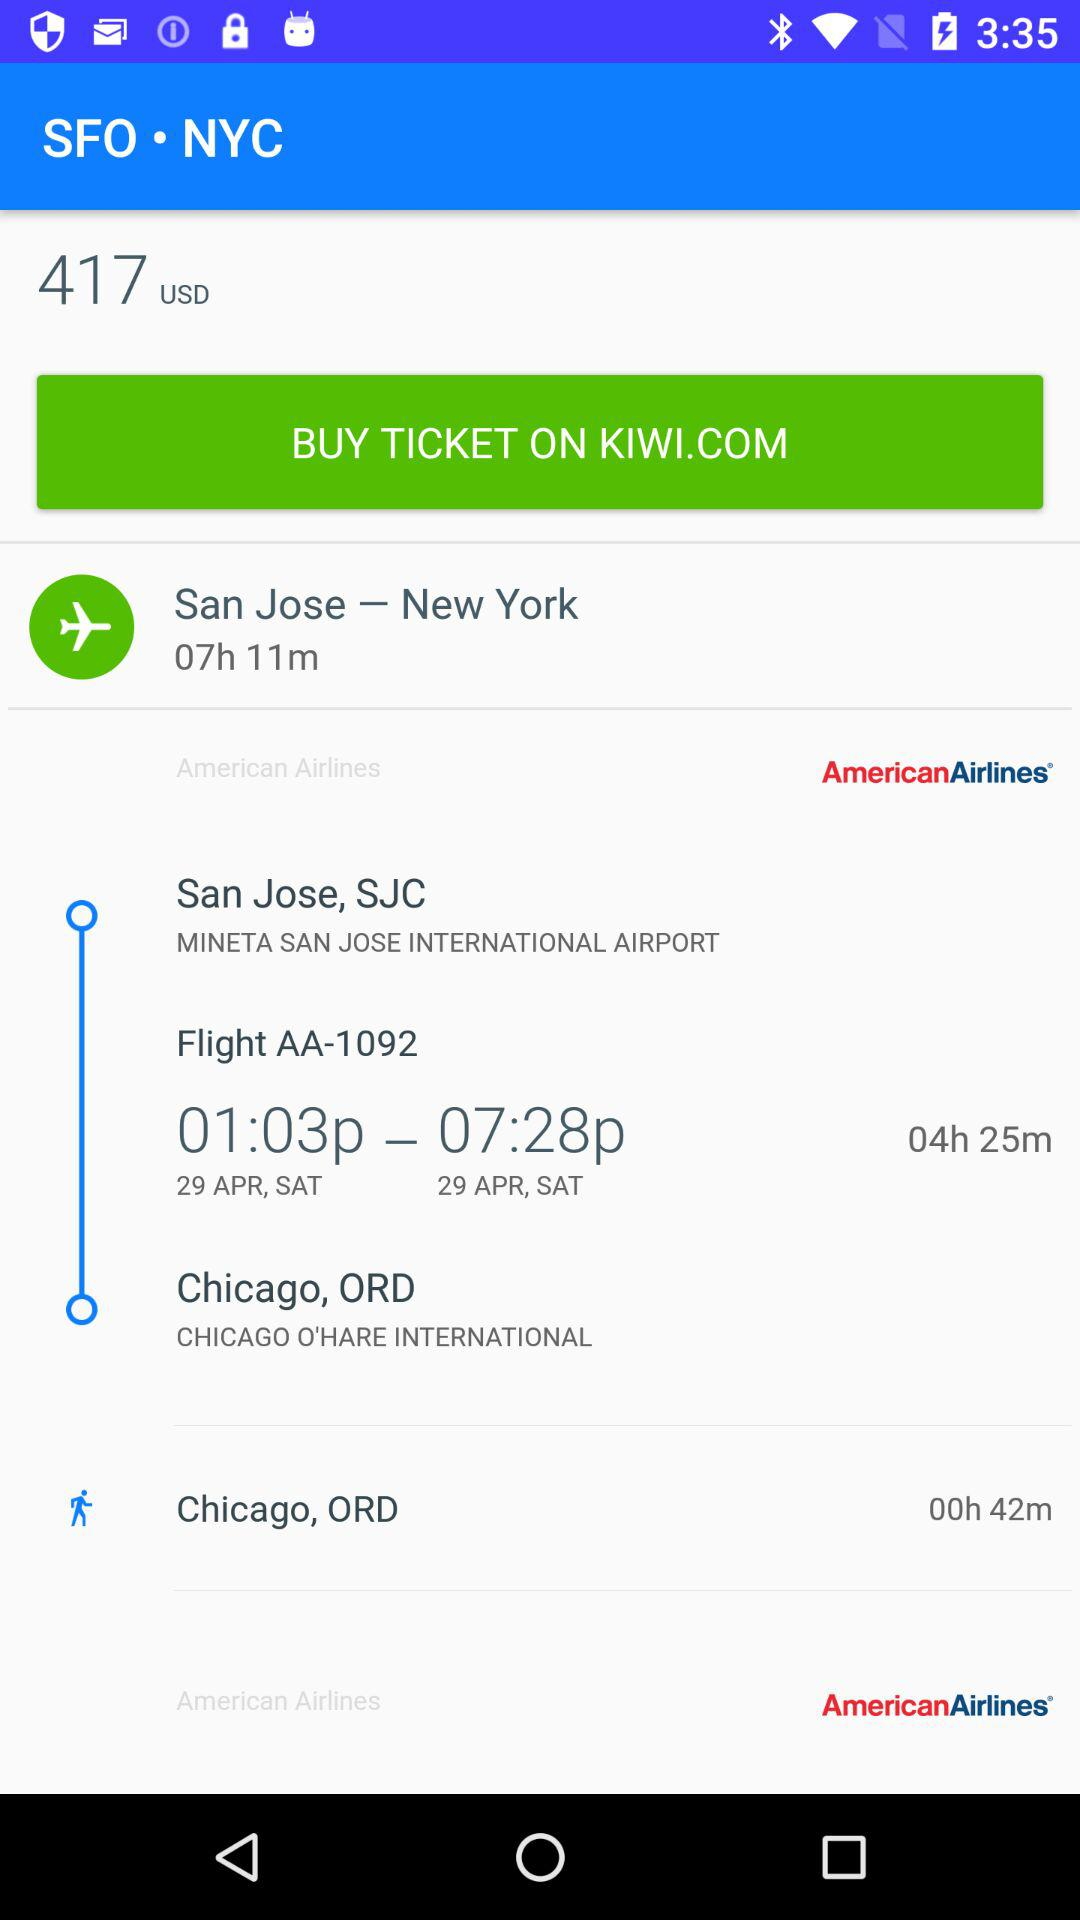What is the departure time and date? The departure date is Saturday, April 29, 2007 and the time is 1:03 p.m. 